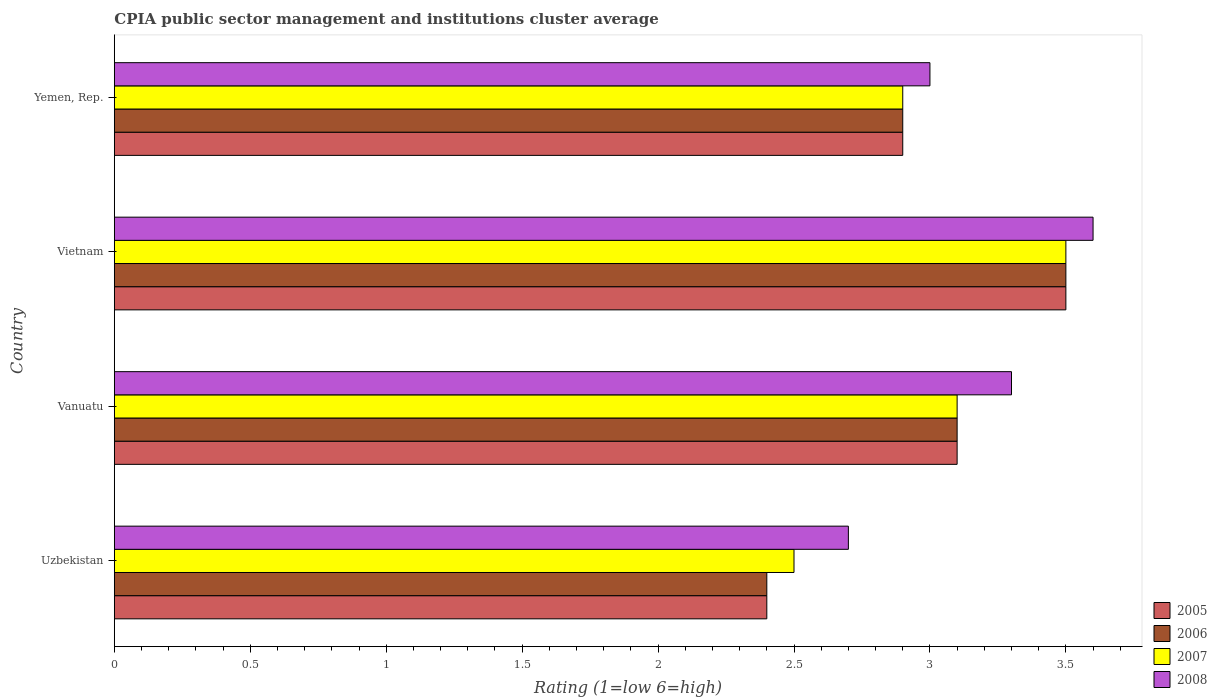How many bars are there on the 2nd tick from the top?
Your response must be concise. 4. What is the label of the 2nd group of bars from the top?
Provide a short and direct response. Vietnam. What is the CPIA rating in 2007 in Vanuatu?
Your answer should be very brief. 3.1. In which country was the CPIA rating in 2006 maximum?
Your answer should be compact. Vietnam. In which country was the CPIA rating in 2007 minimum?
Keep it short and to the point. Uzbekistan. What is the total CPIA rating in 2005 in the graph?
Your response must be concise. 11.9. What is the difference between the CPIA rating in 2006 in Uzbekistan and that in Yemen, Rep.?
Make the answer very short. -0.5. What is the difference between the CPIA rating in 2005 in Uzbekistan and the CPIA rating in 2007 in Vietnam?
Your answer should be very brief. -1.1. What is the average CPIA rating in 2008 per country?
Your answer should be compact. 3.15. What is the difference between the CPIA rating in 2007 and CPIA rating in 2006 in Vanuatu?
Your answer should be very brief. 0. In how many countries, is the CPIA rating in 2005 greater than 2 ?
Your answer should be very brief. 4. What is the ratio of the CPIA rating in 2008 in Uzbekistan to that in Vanuatu?
Your response must be concise. 0.82. Is the CPIA rating in 2008 in Uzbekistan less than that in Vietnam?
Offer a terse response. Yes. Is the difference between the CPIA rating in 2007 in Uzbekistan and Yemen, Rep. greater than the difference between the CPIA rating in 2006 in Uzbekistan and Yemen, Rep.?
Ensure brevity in your answer.  Yes. What is the difference between the highest and the second highest CPIA rating in 2007?
Offer a very short reply. 0.4. What is the difference between the highest and the lowest CPIA rating in 2005?
Your answer should be compact. 1.1. In how many countries, is the CPIA rating in 2005 greater than the average CPIA rating in 2005 taken over all countries?
Your answer should be very brief. 2. Is it the case that in every country, the sum of the CPIA rating in 2008 and CPIA rating in 2007 is greater than the CPIA rating in 2005?
Give a very brief answer. Yes. Are all the bars in the graph horizontal?
Provide a succinct answer. Yes. What is the difference between two consecutive major ticks on the X-axis?
Ensure brevity in your answer.  0.5. Does the graph contain any zero values?
Offer a very short reply. No. Does the graph contain grids?
Provide a succinct answer. No. What is the title of the graph?
Your answer should be compact. CPIA public sector management and institutions cluster average. What is the label or title of the Y-axis?
Make the answer very short. Country. What is the Rating (1=low 6=high) in 2006 in Uzbekistan?
Give a very brief answer. 2.4. What is the Rating (1=low 6=high) in 2007 in Uzbekistan?
Ensure brevity in your answer.  2.5. What is the Rating (1=low 6=high) of 2008 in Uzbekistan?
Ensure brevity in your answer.  2.7. What is the Rating (1=low 6=high) in 2006 in Vanuatu?
Give a very brief answer. 3.1. What is the Rating (1=low 6=high) in 2008 in Vanuatu?
Offer a terse response. 3.3. What is the Rating (1=low 6=high) in 2006 in Vietnam?
Your answer should be very brief. 3.5. What is the Rating (1=low 6=high) of 2008 in Yemen, Rep.?
Provide a succinct answer. 3. Across all countries, what is the maximum Rating (1=low 6=high) in 2005?
Give a very brief answer. 3.5. Across all countries, what is the maximum Rating (1=low 6=high) of 2006?
Your answer should be compact. 3.5. Across all countries, what is the minimum Rating (1=low 6=high) of 2005?
Offer a terse response. 2.4. Across all countries, what is the minimum Rating (1=low 6=high) of 2007?
Provide a short and direct response. 2.5. What is the total Rating (1=low 6=high) in 2006 in the graph?
Provide a short and direct response. 11.9. What is the difference between the Rating (1=low 6=high) in 2005 in Uzbekistan and that in Vanuatu?
Make the answer very short. -0.7. What is the difference between the Rating (1=low 6=high) of 2007 in Uzbekistan and that in Vanuatu?
Your answer should be compact. -0.6. What is the difference between the Rating (1=low 6=high) in 2005 in Uzbekistan and that in Vietnam?
Make the answer very short. -1.1. What is the difference between the Rating (1=low 6=high) in 2007 in Uzbekistan and that in Vietnam?
Make the answer very short. -1. What is the difference between the Rating (1=low 6=high) in 2005 in Uzbekistan and that in Yemen, Rep.?
Your response must be concise. -0.5. What is the difference between the Rating (1=low 6=high) of 2006 in Uzbekistan and that in Yemen, Rep.?
Keep it short and to the point. -0.5. What is the difference between the Rating (1=low 6=high) of 2007 in Uzbekistan and that in Yemen, Rep.?
Your answer should be compact. -0.4. What is the difference between the Rating (1=low 6=high) of 2005 in Vanuatu and that in Yemen, Rep.?
Provide a succinct answer. 0.2. What is the difference between the Rating (1=low 6=high) in 2007 in Vanuatu and that in Yemen, Rep.?
Offer a very short reply. 0.2. What is the difference between the Rating (1=low 6=high) of 2005 in Vietnam and that in Yemen, Rep.?
Offer a very short reply. 0.6. What is the difference between the Rating (1=low 6=high) in 2007 in Vietnam and that in Yemen, Rep.?
Give a very brief answer. 0.6. What is the difference between the Rating (1=low 6=high) in 2005 in Uzbekistan and the Rating (1=low 6=high) in 2006 in Vanuatu?
Your answer should be very brief. -0.7. What is the difference between the Rating (1=low 6=high) of 2005 in Uzbekistan and the Rating (1=low 6=high) of 2007 in Vanuatu?
Offer a very short reply. -0.7. What is the difference between the Rating (1=low 6=high) in 2005 in Uzbekistan and the Rating (1=low 6=high) in 2008 in Vanuatu?
Provide a short and direct response. -0.9. What is the difference between the Rating (1=low 6=high) in 2006 in Uzbekistan and the Rating (1=low 6=high) in 2007 in Vietnam?
Make the answer very short. -1.1. What is the difference between the Rating (1=low 6=high) in 2006 in Uzbekistan and the Rating (1=low 6=high) in 2008 in Vietnam?
Provide a short and direct response. -1.2. What is the difference between the Rating (1=low 6=high) in 2005 in Uzbekistan and the Rating (1=low 6=high) in 2008 in Yemen, Rep.?
Make the answer very short. -0.6. What is the difference between the Rating (1=low 6=high) of 2007 in Uzbekistan and the Rating (1=low 6=high) of 2008 in Yemen, Rep.?
Your answer should be very brief. -0.5. What is the difference between the Rating (1=low 6=high) in 2005 in Vanuatu and the Rating (1=low 6=high) in 2008 in Vietnam?
Provide a short and direct response. -0.5. What is the difference between the Rating (1=low 6=high) in 2005 in Vanuatu and the Rating (1=low 6=high) in 2007 in Yemen, Rep.?
Ensure brevity in your answer.  0.2. What is the difference between the Rating (1=low 6=high) of 2005 in Vanuatu and the Rating (1=low 6=high) of 2008 in Yemen, Rep.?
Your answer should be compact. 0.1. What is the difference between the Rating (1=low 6=high) in 2006 in Vanuatu and the Rating (1=low 6=high) in 2007 in Yemen, Rep.?
Your answer should be very brief. 0.2. What is the difference between the Rating (1=low 6=high) in 2007 in Vanuatu and the Rating (1=low 6=high) in 2008 in Yemen, Rep.?
Give a very brief answer. 0.1. What is the difference between the Rating (1=low 6=high) of 2005 in Vietnam and the Rating (1=low 6=high) of 2007 in Yemen, Rep.?
Your response must be concise. 0.6. What is the difference between the Rating (1=low 6=high) of 2005 in Vietnam and the Rating (1=low 6=high) of 2008 in Yemen, Rep.?
Ensure brevity in your answer.  0.5. What is the average Rating (1=low 6=high) of 2005 per country?
Offer a terse response. 2.98. What is the average Rating (1=low 6=high) in 2006 per country?
Give a very brief answer. 2.98. What is the average Rating (1=low 6=high) of 2007 per country?
Give a very brief answer. 3. What is the average Rating (1=low 6=high) of 2008 per country?
Your answer should be compact. 3.15. What is the difference between the Rating (1=low 6=high) in 2006 and Rating (1=low 6=high) in 2007 in Uzbekistan?
Your answer should be compact. -0.1. What is the difference between the Rating (1=low 6=high) of 2007 and Rating (1=low 6=high) of 2008 in Uzbekistan?
Your answer should be compact. -0.2. What is the difference between the Rating (1=low 6=high) in 2005 and Rating (1=low 6=high) in 2007 in Vanuatu?
Your answer should be very brief. 0. What is the difference between the Rating (1=low 6=high) in 2005 and Rating (1=low 6=high) in 2008 in Vanuatu?
Offer a terse response. -0.2. What is the difference between the Rating (1=low 6=high) in 2006 and Rating (1=low 6=high) in 2008 in Vanuatu?
Make the answer very short. -0.2. What is the difference between the Rating (1=low 6=high) of 2007 and Rating (1=low 6=high) of 2008 in Vanuatu?
Give a very brief answer. -0.2. What is the difference between the Rating (1=low 6=high) in 2005 and Rating (1=low 6=high) in 2008 in Vietnam?
Your answer should be very brief. -0.1. What is the difference between the Rating (1=low 6=high) of 2007 and Rating (1=low 6=high) of 2008 in Vietnam?
Keep it short and to the point. -0.1. What is the difference between the Rating (1=low 6=high) of 2005 and Rating (1=low 6=high) of 2008 in Yemen, Rep.?
Offer a terse response. -0.1. What is the difference between the Rating (1=low 6=high) in 2006 and Rating (1=low 6=high) in 2008 in Yemen, Rep.?
Make the answer very short. -0.1. What is the difference between the Rating (1=low 6=high) of 2007 and Rating (1=low 6=high) of 2008 in Yemen, Rep.?
Keep it short and to the point. -0.1. What is the ratio of the Rating (1=low 6=high) in 2005 in Uzbekistan to that in Vanuatu?
Ensure brevity in your answer.  0.77. What is the ratio of the Rating (1=low 6=high) of 2006 in Uzbekistan to that in Vanuatu?
Your response must be concise. 0.77. What is the ratio of the Rating (1=low 6=high) in 2007 in Uzbekistan to that in Vanuatu?
Offer a terse response. 0.81. What is the ratio of the Rating (1=low 6=high) of 2008 in Uzbekistan to that in Vanuatu?
Ensure brevity in your answer.  0.82. What is the ratio of the Rating (1=low 6=high) of 2005 in Uzbekistan to that in Vietnam?
Keep it short and to the point. 0.69. What is the ratio of the Rating (1=low 6=high) of 2006 in Uzbekistan to that in Vietnam?
Your answer should be compact. 0.69. What is the ratio of the Rating (1=low 6=high) in 2005 in Uzbekistan to that in Yemen, Rep.?
Your answer should be compact. 0.83. What is the ratio of the Rating (1=low 6=high) in 2006 in Uzbekistan to that in Yemen, Rep.?
Give a very brief answer. 0.83. What is the ratio of the Rating (1=low 6=high) of 2007 in Uzbekistan to that in Yemen, Rep.?
Provide a succinct answer. 0.86. What is the ratio of the Rating (1=low 6=high) of 2005 in Vanuatu to that in Vietnam?
Make the answer very short. 0.89. What is the ratio of the Rating (1=low 6=high) in 2006 in Vanuatu to that in Vietnam?
Make the answer very short. 0.89. What is the ratio of the Rating (1=low 6=high) of 2007 in Vanuatu to that in Vietnam?
Offer a terse response. 0.89. What is the ratio of the Rating (1=low 6=high) in 2005 in Vanuatu to that in Yemen, Rep.?
Give a very brief answer. 1.07. What is the ratio of the Rating (1=low 6=high) of 2006 in Vanuatu to that in Yemen, Rep.?
Offer a terse response. 1.07. What is the ratio of the Rating (1=low 6=high) in 2007 in Vanuatu to that in Yemen, Rep.?
Make the answer very short. 1.07. What is the ratio of the Rating (1=low 6=high) of 2005 in Vietnam to that in Yemen, Rep.?
Your answer should be very brief. 1.21. What is the ratio of the Rating (1=low 6=high) of 2006 in Vietnam to that in Yemen, Rep.?
Provide a short and direct response. 1.21. What is the ratio of the Rating (1=low 6=high) of 2007 in Vietnam to that in Yemen, Rep.?
Offer a terse response. 1.21. What is the ratio of the Rating (1=low 6=high) of 2008 in Vietnam to that in Yemen, Rep.?
Provide a short and direct response. 1.2. What is the difference between the highest and the second highest Rating (1=low 6=high) of 2006?
Provide a short and direct response. 0.4. What is the difference between the highest and the second highest Rating (1=low 6=high) in 2008?
Make the answer very short. 0.3. What is the difference between the highest and the lowest Rating (1=low 6=high) in 2006?
Provide a succinct answer. 1.1. 